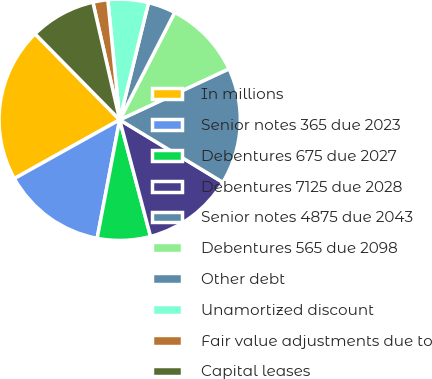Convert chart to OTSL. <chart><loc_0><loc_0><loc_500><loc_500><pie_chart><fcel>In millions<fcel>Senior notes 365 due 2023<fcel>Debentures 675 due 2027<fcel>Debentures 7125 due 2028<fcel>Senior notes 4875 due 2043<fcel>Debentures 565 due 2098<fcel>Other debt<fcel>Unamortized discount<fcel>Fair value adjustments due to<fcel>Capital leases<nl><fcel>20.72%<fcel>13.91%<fcel>7.11%<fcel>12.21%<fcel>15.62%<fcel>10.51%<fcel>3.7%<fcel>5.41%<fcel>2.0%<fcel>8.81%<nl></chart> 